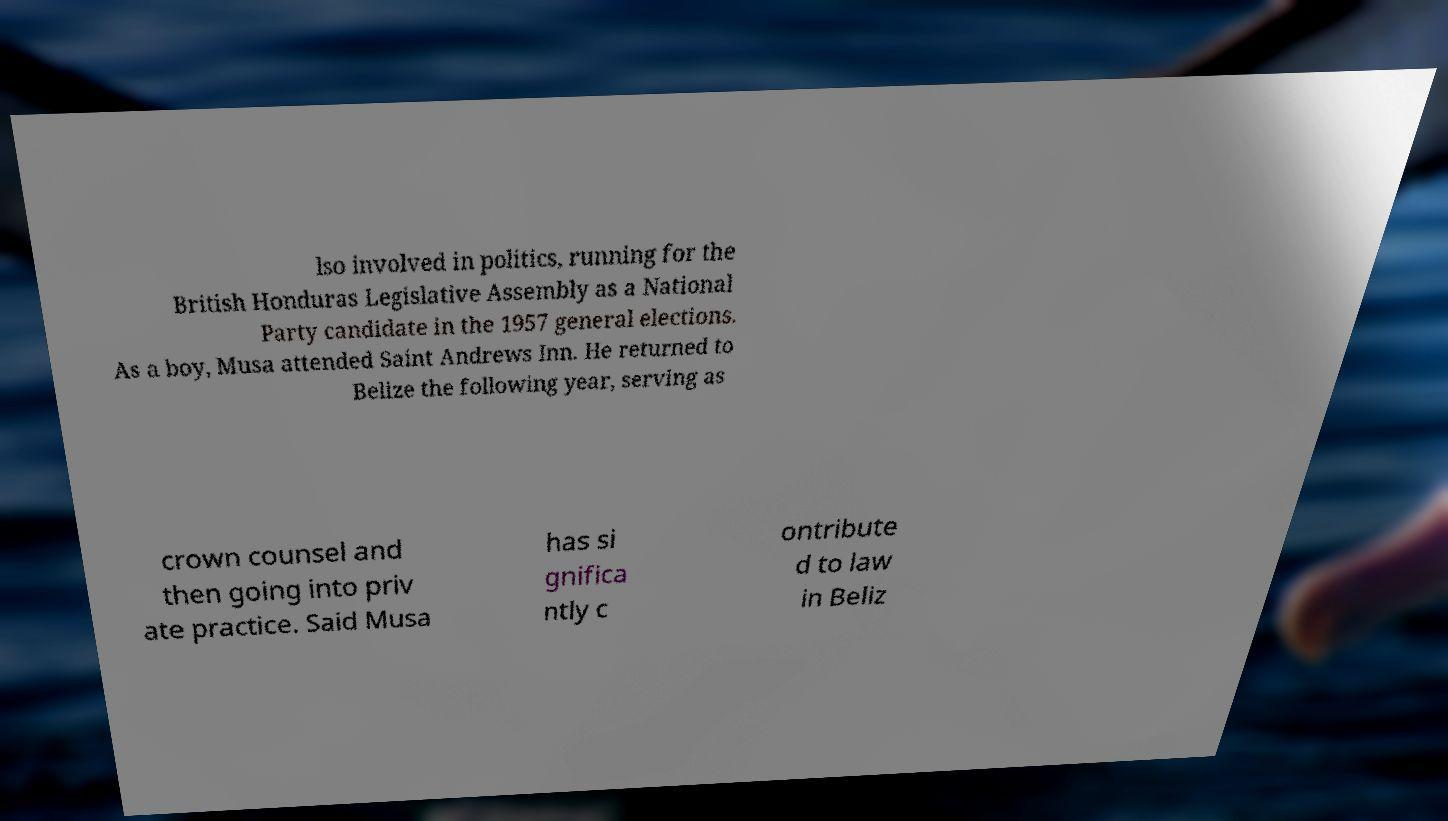Could you assist in decoding the text presented in this image and type it out clearly? lso involved in politics, running for the British Honduras Legislative Assembly as a National Party candidate in the 1957 general elections. As a boy, Musa attended Saint Andrews Inn. He returned to Belize the following year, serving as crown counsel and then going into priv ate practice. Said Musa has si gnifica ntly c ontribute d to law in Beliz 